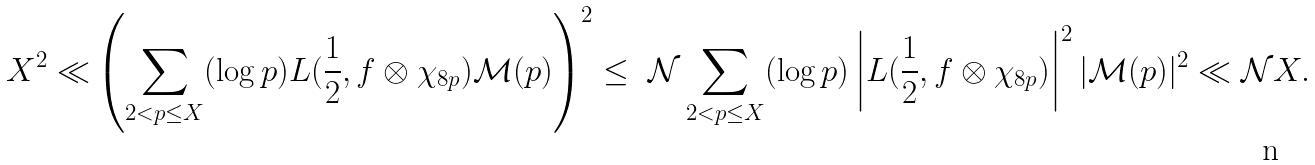Convert formula to latex. <formula><loc_0><loc_0><loc_500><loc_500>X ^ { 2 } \ll & \left ( \sum _ { 2 < p \leq X } ( \log p ) L ( \frac { 1 } { 2 } , f \otimes \chi _ { 8 p } ) \mathcal { M } ( p ) \right ) ^ { 2 } \leq \ \mathcal { N } \sum _ { 2 < p \leq X } ( \log p ) \left | L ( \frac { 1 } { 2 } , f \otimes \chi _ { 8 p } ) \right | ^ { 2 } | \mathcal { M } ( p ) | ^ { 2 } \ll \mathcal { N } X .</formula> 